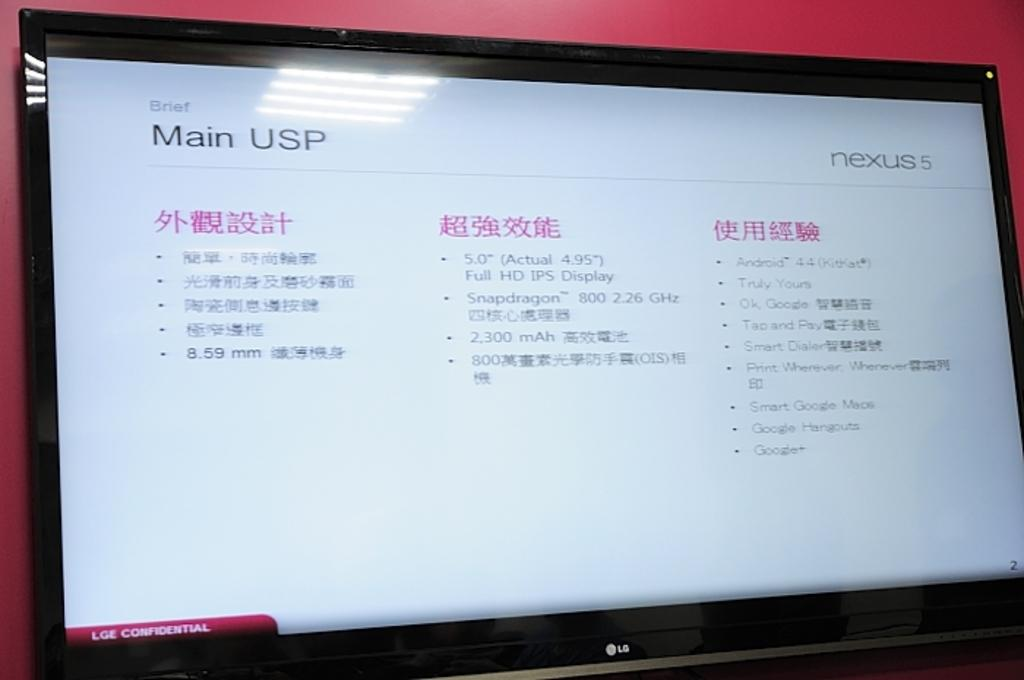Provide a one-sentence caption for the provided image. The website has the title Main USP on the screen. 